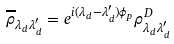Convert formula to latex. <formula><loc_0><loc_0><loc_500><loc_500>\overline { \rho } _ { \lambda _ { d } \lambda ^ { \prime } _ { d } } = e ^ { i ( \lambda _ { d } - \lambda ^ { \prime } _ { d } ) \phi _ { p } } \rho ^ { D } _ { \lambda _ { d } \lambda ^ { \prime } _ { d } }</formula> 